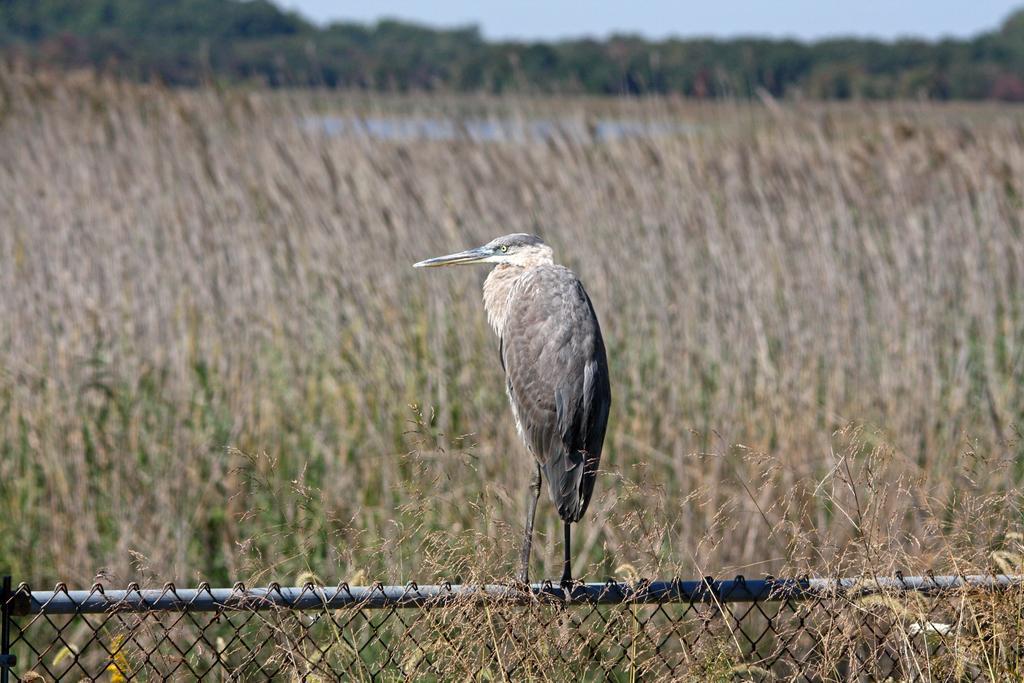In one or two sentences, can you explain what this image depicts? In the background we can see the sky, trees. In this picture we can see the field. At the bottom portion of the picture we can see the fence and we can see a bird on a pole. 